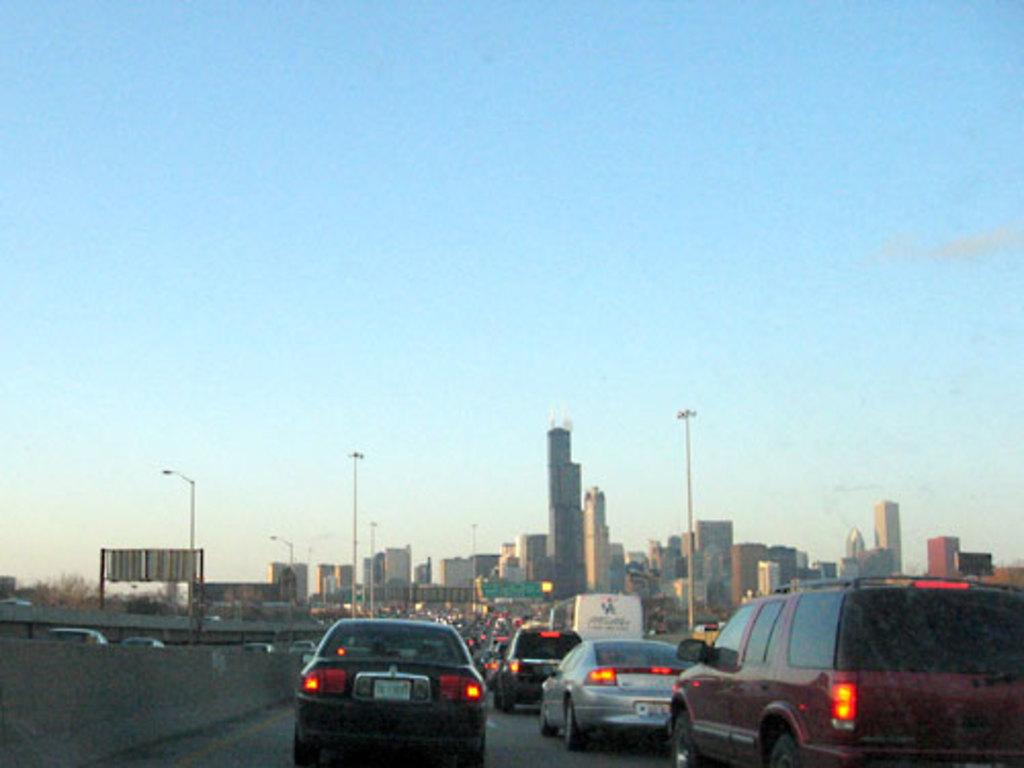What is the main feature of the image? There is a road in the image. What can be seen on the road? There are many vehicles on the road. What is located next to the road? There is a wall visible to the side of the road. What can be seen in the distance? There are buildings and poles in the background of the image. What is the color of the sky in the image? The sky is blue in the background of the image. What channel is the silver object being broadcasted on in the image? There is no silver object or channel present in the image. 